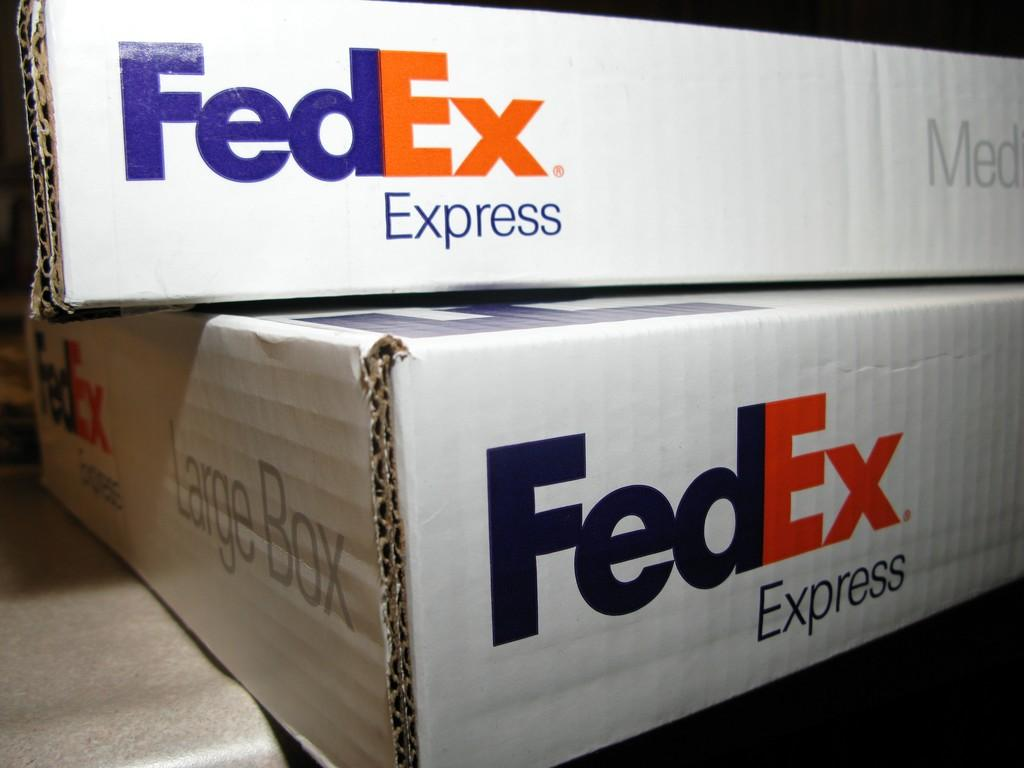<image>
Create a compact narrative representing the image presented. A medium FedEx box on top of a large FedEx box 